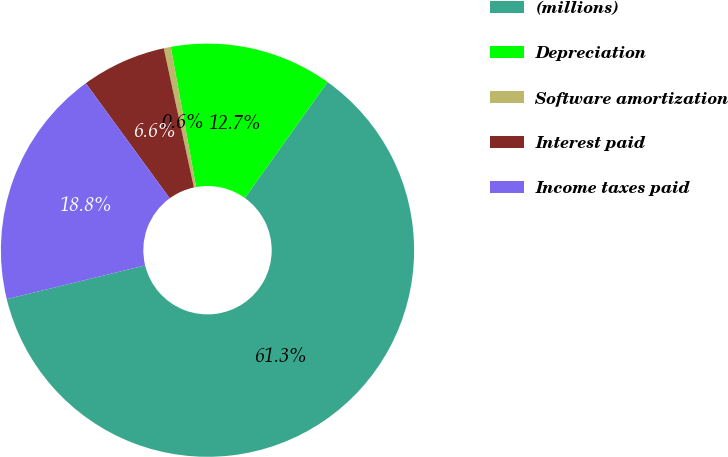<chart> <loc_0><loc_0><loc_500><loc_500><pie_chart><fcel>(millions)<fcel>Depreciation<fcel>Software amortization<fcel>Interest paid<fcel>Income taxes paid<nl><fcel>61.33%<fcel>12.71%<fcel>0.55%<fcel>6.63%<fcel>18.78%<nl></chart> 